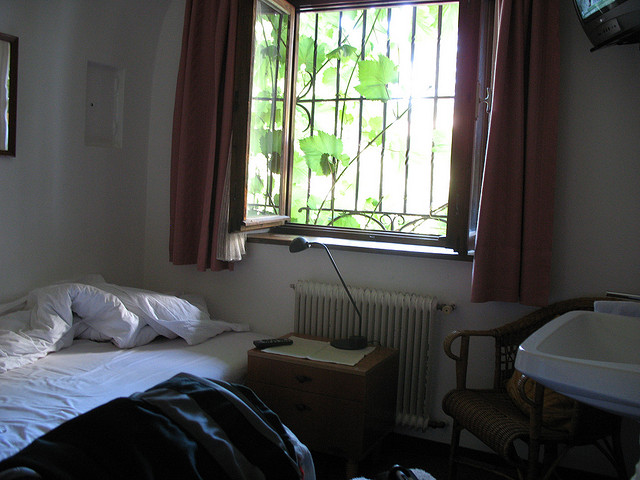<image>Is the phone cordless? I don't know if the phone is cordless. It could be either cordless or not. What type of print is on the curtain? It is ambiguous what type of print is on the curtain as it could be solid or have no print. What type of print is on the curtain? There is no print on the curtain. Is the phone cordless? I don't know if the phone is cordless. It can be both cordless or not cordless. 